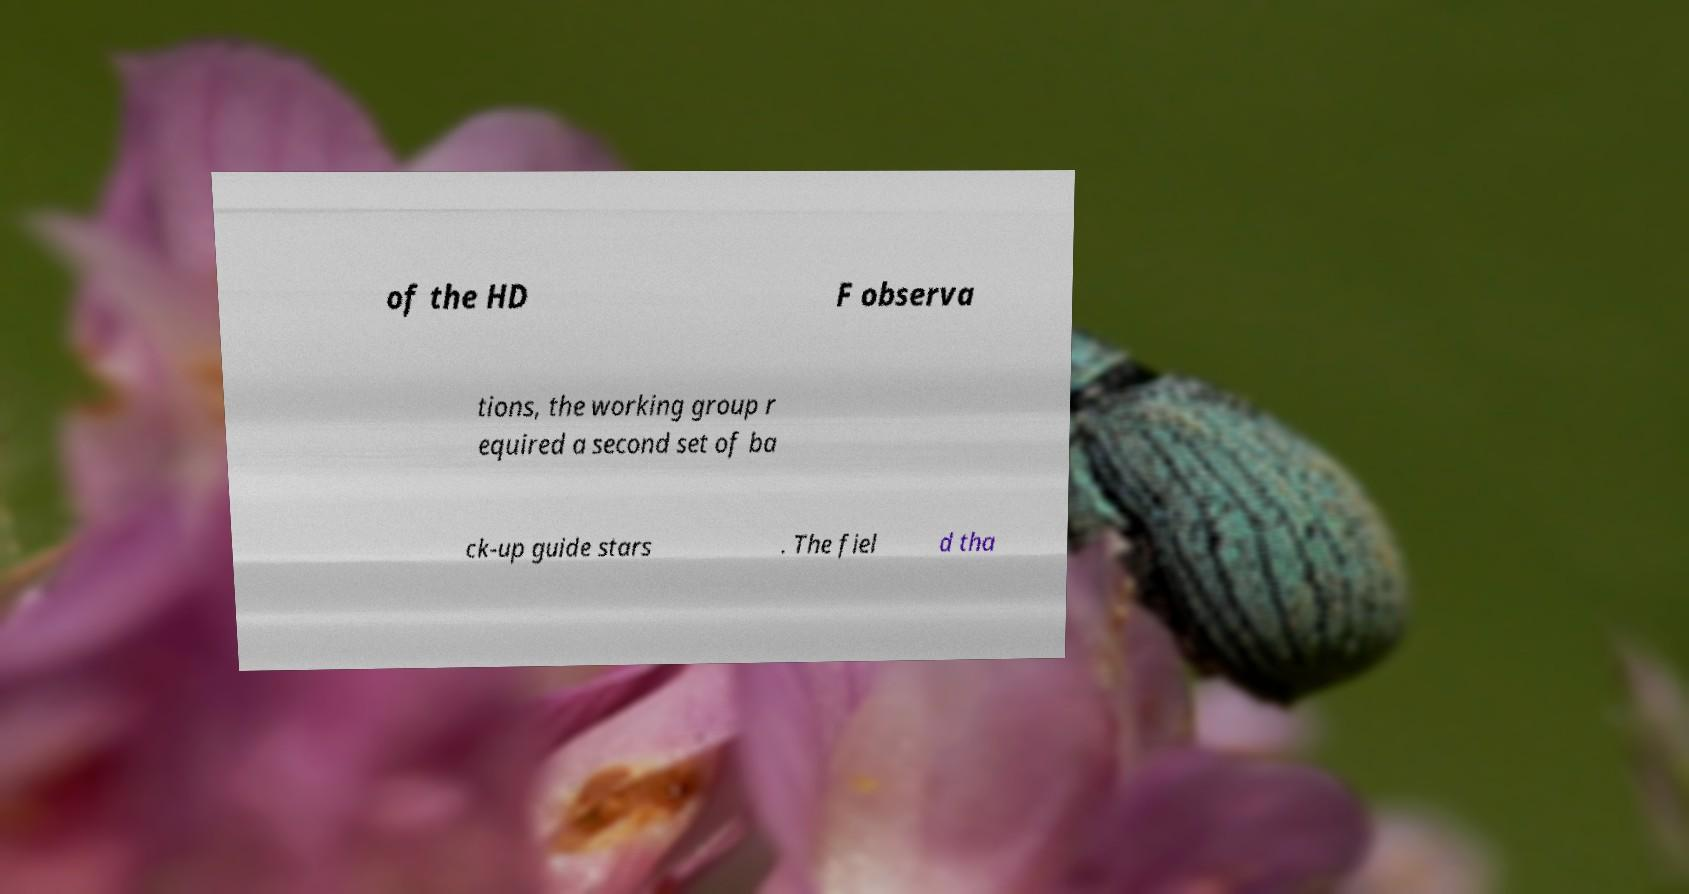What messages or text are displayed in this image? I need them in a readable, typed format. of the HD F observa tions, the working group r equired a second set of ba ck-up guide stars . The fiel d tha 